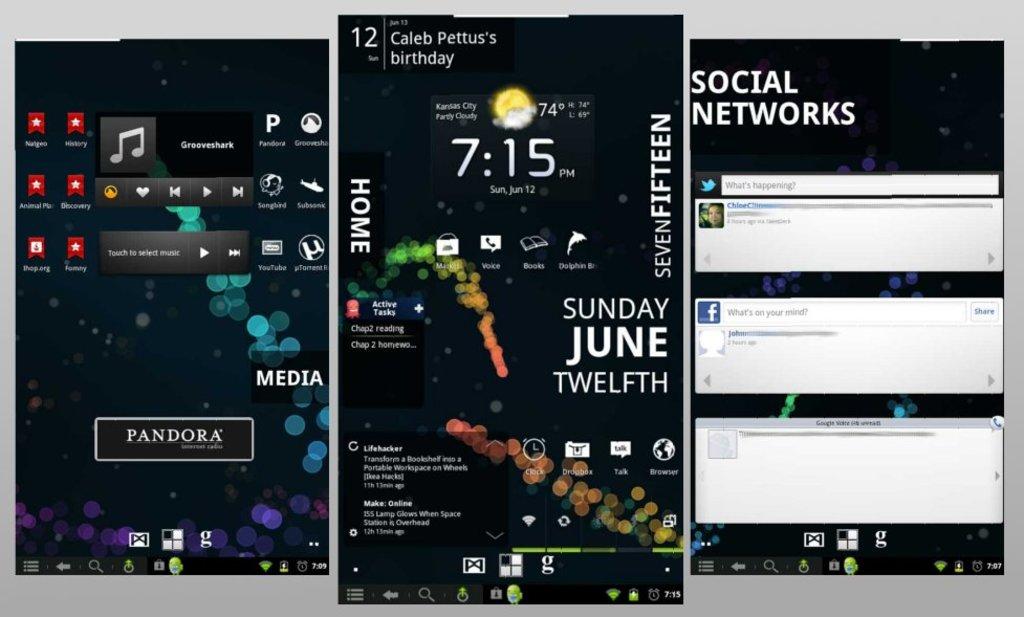What is the time on this phone?
Give a very brief answer. 7:15. What day of the week was this screenshot taken?
Provide a succinct answer. Sunday. 